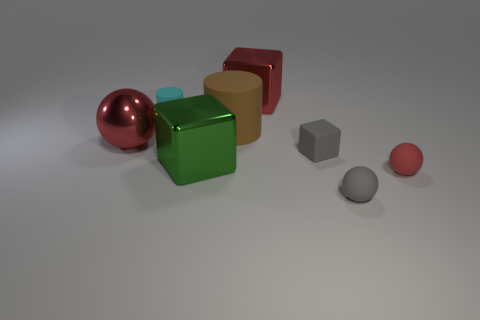Add 1 large green matte objects. How many objects exist? 9 Subtract all brown cylinders. How many cylinders are left? 1 Subtract all red balls. How many balls are left? 1 Subtract 0 blue spheres. How many objects are left? 8 Subtract all cylinders. How many objects are left? 6 Subtract 1 cubes. How many cubes are left? 2 Subtract all red blocks. Subtract all green cylinders. How many blocks are left? 2 Subtract all red cylinders. How many red balls are left? 2 Subtract all large brown metal spheres. Subtract all red rubber objects. How many objects are left? 7 Add 7 tiny gray blocks. How many tiny gray blocks are left? 8 